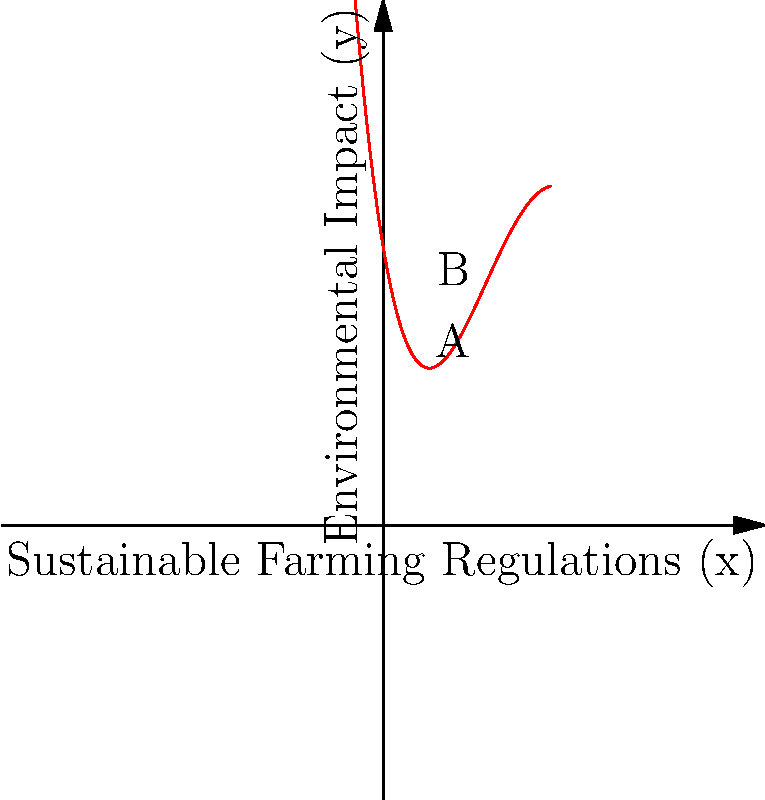The graph represents the environmental impact (y) of coffee production as a function of sustainable farming regulations (x), modeled by a quartic polynomial. Identify the interval of regulation levels where increasing regulations leads to a decrease in environmental impact, and explain its significance for policy-making in the coffee industry. To solve this problem, we need to analyze the graph and understand its implications:

1. The environmental impact is represented by the y-axis, while the level of sustainable farming regulations is shown on the x-axis.

2. We need to find the interval where an increase in x (regulations) leads to a decrease in y (environmental impact).

3. Examining the graph, we can see that the curve decreases from point A to point B.

4. Point A is approximately at x = 1.5, and point B is at x = 3.5.

5. This means that between regulation levels 1.5 and 3.5, increasing regulations leads to a decrease in environmental impact.

6. Significance for policy-making:
   a) This interval represents an optimal range for implementing sustainable farming regulations.
   b) Within this range, stricter regulations result in reduced environmental impact, benefiting both the environment and the coffee industry's sustainability.
   c) Policy analysts should recommend focusing efforts on regulations within this range for maximum effectiveness.
   d) Beyond this interval (x > 3.5), increasing regulations may lead to diminishing returns or even increased environmental impact, possibly due to unintended consequences or over-regulation.

7. The quartic nature of the polynomial suggests that the relationship between regulations and environmental impact is complex, with multiple inflection points and varying rates of change.
Answer: The interval [1.5, 3.5] represents the optimal range for sustainable farming regulations, where increased regulations lead to decreased environmental impact in coffee production. 